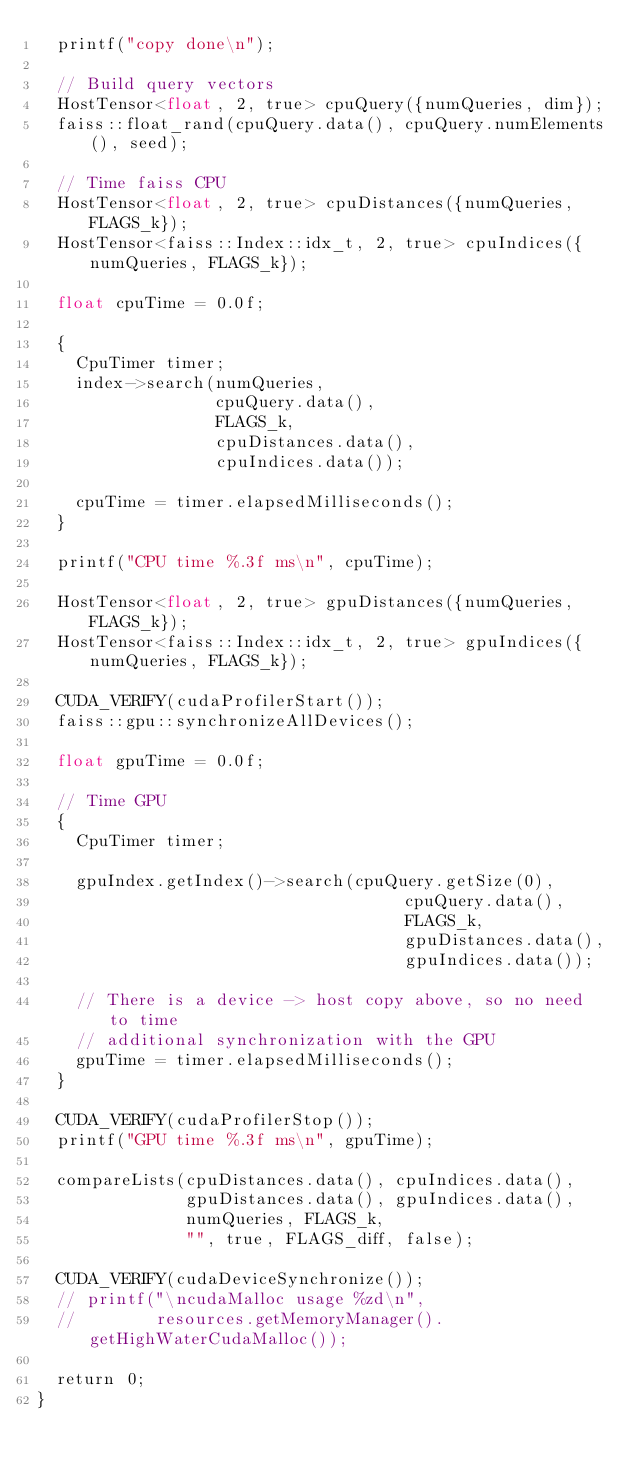Convert code to text. <code><loc_0><loc_0><loc_500><loc_500><_Cuda_>  printf("copy done\n");

  // Build query vectors
  HostTensor<float, 2, true> cpuQuery({numQueries, dim});
  faiss::float_rand(cpuQuery.data(), cpuQuery.numElements(), seed);

  // Time faiss CPU
  HostTensor<float, 2, true> cpuDistances({numQueries, FLAGS_k});
  HostTensor<faiss::Index::idx_t, 2, true> cpuIndices({numQueries, FLAGS_k});

  float cpuTime = 0.0f;

  {
    CpuTimer timer;
    index->search(numQueries,
                  cpuQuery.data(),
                  FLAGS_k,
                  cpuDistances.data(),
                  cpuIndices.data());

    cpuTime = timer.elapsedMilliseconds();
  }

  printf("CPU time %.3f ms\n", cpuTime);

  HostTensor<float, 2, true> gpuDistances({numQueries, FLAGS_k});
  HostTensor<faiss::Index::idx_t, 2, true> gpuIndices({numQueries, FLAGS_k});

  CUDA_VERIFY(cudaProfilerStart());
  faiss::gpu::synchronizeAllDevices();

  float gpuTime = 0.0f;

  // Time GPU
  {
    CpuTimer timer;

    gpuIndex.getIndex()->search(cpuQuery.getSize(0),
                                     cpuQuery.data(),
                                     FLAGS_k,
                                     gpuDistances.data(),
                                     gpuIndices.data());

    // There is a device -> host copy above, so no need to time
    // additional synchronization with the GPU
    gpuTime = timer.elapsedMilliseconds();
  }

  CUDA_VERIFY(cudaProfilerStop());
  printf("GPU time %.3f ms\n", gpuTime);

  compareLists(cpuDistances.data(), cpuIndices.data(),
               gpuDistances.data(), gpuIndices.data(),
               numQueries, FLAGS_k,
               "", true, FLAGS_diff, false);

  CUDA_VERIFY(cudaDeviceSynchronize());
  // printf("\ncudaMalloc usage %zd\n",
  //        resources.getMemoryManager().getHighWaterCudaMalloc());

  return 0;
}
</code> 